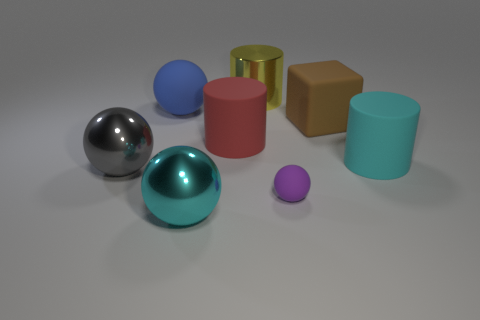Is the shape of the large cyan metal object the same as the thing behind the blue thing?
Provide a succinct answer. No. The large shiny object left of the big object that is in front of the large shiny ball behind the cyan metallic sphere is what color?
Ensure brevity in your answer.  Gray. There is a metal object to the left of the blue thing; is it the same shape as the cyan rubber object?
Keep it short and to the point. No. What is the brown block made of?
Ensure brevity in your answer.  Rubber. There is a big cyan thing that is left of the large metal object behind the big metallic sphere that is on the left side of the cyan metal thing; what is its shape?
Your answer should be compact. Sphere. How many other things are the same shape as the big red matte thing?
Keep it short and to the point. 2. How many rubber spheres are there?
Offer a terse response. 2. What number of objects are red cylinders or big yellow things?
Your response must be concise. 2. Are there any large things right of the big blue matte object?
Give a very brief answer. Yes. Is the number of large cyan cylinders in front of the yellow metal thing greater than the number of red things to the left of the big red cylinder?
Your response must be concise. Yes. 